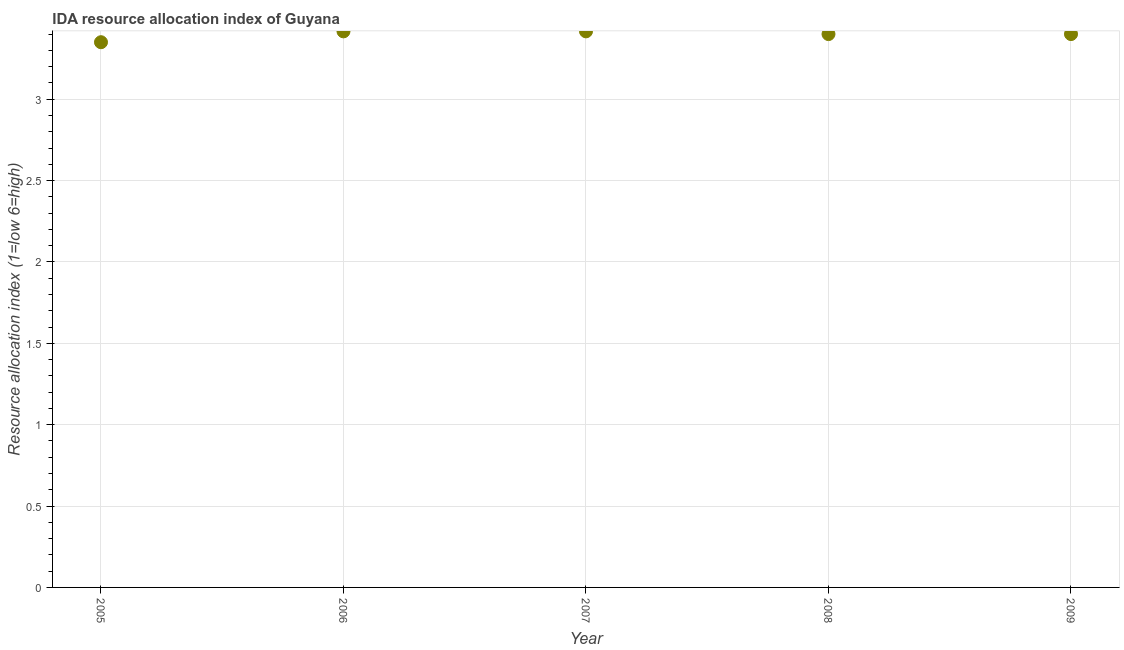What is the ida resource allocation index in 2005?
Offer a terse response. 3.35. Across all years, what is the maximum ida resource allocation index?
Offer a very short reply. 3.42. Across all years, what is the minimum ida resource allocation index?
Your answer should be compact. 3.35. In which year was the ida resource allocation index minimum?
Ensure brevity in your answer.  2005. What is the sum of the ida resource allocation index?
Provide a succinct answer. 16.98. What is the difference between the ida resource allocation index in 2006 and 2007?
Provide a succinct answer. 0. What is the average ida resource allocation index per year?
Your response must be concise. 3.4. Is the ida resource allocation index in 2005 less than that in 2006?
Your answer should be very brief. Yes. Is the sum of the ida resource allocation index in 2006 and 2008 greater than the maximum ida resource allocation index across all years?
Ensure brevity in your answer.  Yes. What is the difference between the highest and the lowest ida resource allocation index?
Offer a very short reply. 0.07. In how many years, is the ida resource allocation index greater than the average ida resource allocation index taken over all years?
Your answer should be very brief. 4. How many dotlines are there?
Give a very brief answer. 1. How many years are there in the graph?
Ensure brevity in your answer.  5. What is the difference between two consecutive major ticks on the Y-axis?
Provide a short and direct response. 0.5. Does the graph contain grids?
Give a very brief answer. Yes. What is the title of the graph?
Give a very brief answer. IDA resource allocation index of Guyana. What is the label or title of the X-axis?
Offer a very short reply. Year. What is the label or title of the Y-axis?
Make the answer very short. Resource allocation index (1=low 6=high). What is the Resource allocation index (1=low 6=high) in 2005?
Your answer should be compact. 3.35. What is the Resource allocation index (1=low 6=high) in 2006?
Offer a very short reply. 3.42. What is the Resource allocation index (1=low 6=high) in 2007?
Provide a succinct answer. 3.42. What is the Resource allocation index (1=low 6=high) in 2008?
Provide a short and direct response. 3.4. What is the Resource allocation index (1=low 6=high) in 2009?
Keep it short and to the point. 3.4. What is the difference between the Resource allocation index (1=low 6=high) in 2005 and 2006?
Your answer should be compact. -0.07. What is the difference between the Resource allocation index (1=low 6=high) in 2005 and 2007?
Your answer should be compact. -0.07. What is the difference between the Resource allocation index (1=low 6=high) in 2006 and 2007?
Your response must be concise. 0. What is the difference between the Resource allocation index (1=low 6=high) in 2006 and 2008?
Ensure brevity in your answer.  0.02. What is the difference between the Resource allocation index (1=low 6=high) in 2006 and 2009?
Your response must be concise. 0.02. What is the difference between the Resource allocation index (1=low 6=high) in 2007 and 2008?
Give a very brief answer. 0.02. What is the difference between the Resource allocation index (1=low 6=high) in 2007 and 2009?
Offer a very short reply. 0.02. What is the ratio of the Resource allocation index (1=low 6=high) in 2005 to that in 2007?
Your answer should be very brief. 0.98. What is the ratio of the Resource allocation index (1=low 6=high) in 2005 to that in 2008?
Make the answer very short. 0.98. What is the ratio of the Resource allocation index (1=low 6=high) in 2005 to that in 2009?
Ensure brevity in your answer.  0.98. What is the ratio of the Resource allocation index (1=low 6=high) in 2007 to that in 2009?
Provide a short and direct response. 1. What is the ratio of the Resource allocation index (1=low 6=high) in 2008 to that in 2009?
Provide a short and direct response. 1. 